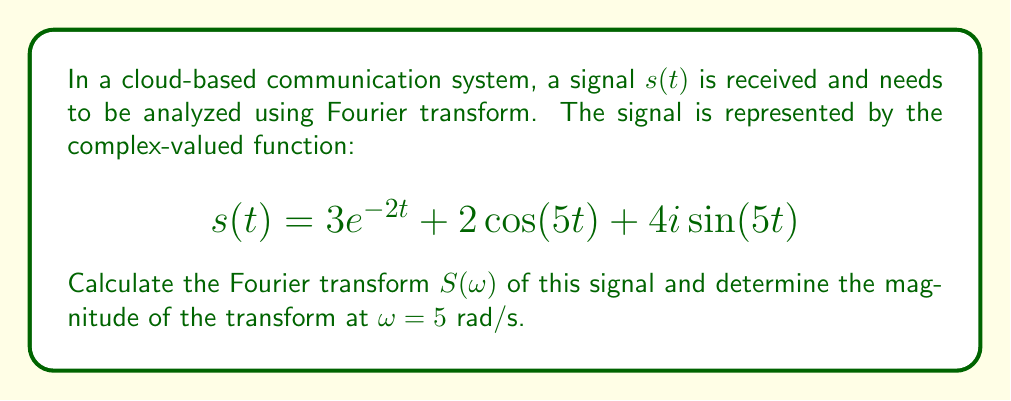What is the answer to this math problem? To solve this problem, we'll follow these steps:

1) Recall the Fourier transform formula:
   $$S(\omega) = \int_{-\infty}^{\infty} s(t) e^{-i\omega t} dt$$

2) Break down the signal into its components:
   a) $3e^{-2t}$
   b) $2\cos(5t)$
   c) $4i\sin(5t)$

3) Calculate the Fourier transform for each component:

   a) For $3e^{-2t}$:
      $$\mathcal{F}\{3e^{-2t}\} = \frac{3}{2+i\omega}$$

   b) For $2\cos(5t)$:
      $$\mathcal{F}\{2\cos(5t)\} = \pi[\delta(\omega-5) + \delta(\omega+5)]$$

   c) For $4i\sin(5t)$:
      $$\mathcal{F}\{4i\sin(5t)\} = 2\pi i[\delta(\omega-5) - \delta(\omega+5)]$$

4) Sum up the components to get $S(\omega)$:
   $$S(\omega) = \frac{3}{2+i\omega} + \pi[\delta(\omega-5) + \delta(\omega+5)] + 2\pi i[\delta(\omega-5) - \delta(\omega+5)]$$

5) To find the magnitude at $\omega = 5$ rad/s, we need to evaluate $|S(5)|$:
   
   At $\omega = 5$, the delta functions become:
   $$\delta(5-5) = 1, \delta(5+5) = 0$$

   So, $S(5) = \frac{3}{2+5i} + \pi + 2\pi i$

6) Calculate the magnitude:
   $$|S(5)| = \left|\frac{3}{2+5i} + \pi + 2\pi i\right|$$
   
   $$= \left|\frac{3(2-5i)}{(2+5i)(2-5i)} + \pi + 2\pi i\right|$$
   
   $$= \left|\frac{6-15i}{29} + \pi + 2\pi i\right|$$
   
   $$= \left|\frac{6}{29} - \frac{15i}{29} + \pi + 2\pi i\right|$$
   
   $$= \left|(\frac{6}{29} + \pi) + (2\pi - \frac{15}{29})i\right|$$

7) Use the magnitude formula for a complex number $a + bi$: $\sqrt{a^2 + b^2}$

   $$|S(5)| = \sqrt{(\frac{6}{29} + \pi)^2 + (2\pi - \frac{15}{29})^2}$$
Answer: $$|S(5)| = \sqrt{(\frac{6}{29} + \pi)^2 + (2\pi - \frac{15}{29})^2} \approx 7.31$$ 